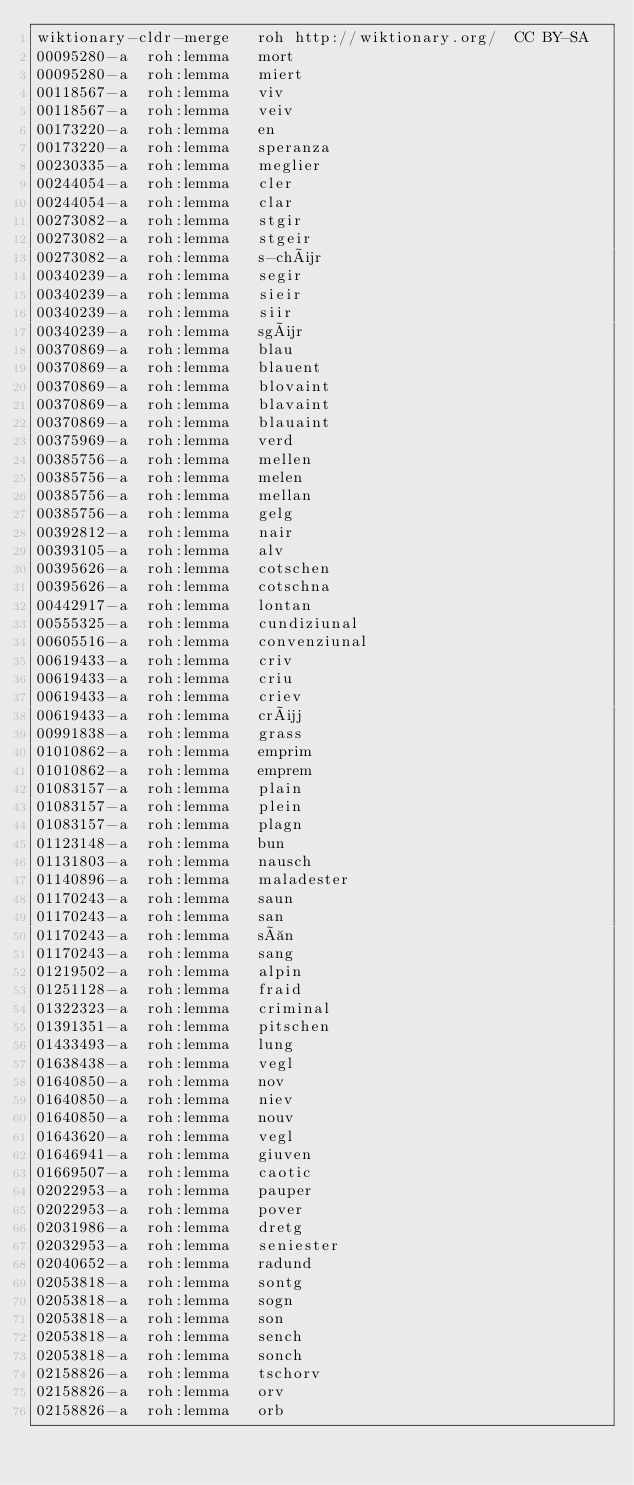<code> <loc_0><loc_0><loc_500><loc_500><_SQL_>wiktionary-cldr-merge	roh	http://wiktionary.org/	CC BY-SA
00095280-a	roh:lemma	mort	
00095280-a	roh:lemma	miert	
00118567-a	roh:lemma	viv	
00118567-a	roh:lemma	veiv	
00173220-a	roh:lemma	en	
00173220-a	roh:lemma	speranza	
00230335-a	roh:lemma	meglier	
00244054-a	roh:lemma	cler	
00244054-a	roh:lemma	clar	
00273082-a	roh:lemma	stgir	
00273082-a	roh:lemma	stgeir	
00273082-a	roh:lemma	s-chür	
00340239-a	roh:lemma	segir	
00340239-a	roh:lemma	sieir	
00340239-a	roh:lemma	siir	
00340239-a	roh:lemma	sgür	
00370869-a	roh:lemma	blau	
00370869-a	roh:lemma	blauent	
00370869-a	roh:lemma	blovaint	
00370869-a	roh:lemma	blavaint	
00370869-a	roh:lemma	blauaint	
00375969-a	roh:lemma	verd	
00385756-a	roh:lemma	mellen	
00385756-a	roh:lemma	melen	
00385756-a	roh:lemma	mellan	
00385756-a	roh:lemma	gelg	
00392812-a	roh:lemma	nair	
00393105-a	roh:lemma	alv	
00395626-a	roh:lemma	cotschen	
00395626-a	roh:lemma	cotschna	
00442917-a	roh:lemma	lontan	
00555325-a	roh:lemma	cundiziunal	
00605516-a	roh:lemma	convenziunal	
00619433-a	roh:lemma	criv	
00619433-a	roh:lemma	criu	
00619433-a	roh:lemma	criev	
00619433-a	roh:lemma	crüj	
00991838-a	roh:lemma	grass	
01010862-a	roh:lemma	emprim	
01010862-a	roh:lemma	emprem	
01083157-a	roh:lemma	plain	
01083157-a	roh:lemma	plein	
01083157-a	roh:lemma	plagn	
01123148-a	roh:lemma	bun	
01131803-a	roh:lemma	nausch	
01140896-a	roh:lemma	maladester	
01170243-a	roh:lemma	saun	
01170243-a	roh:lemma	san	
01170243-a	roh:lemma	sàn	
01170243-a	roh:lemma	sang	
01219502-a	roh:lemma	alpin	
01251128-a	roh:lemma	fraid	
01322323-a	roh:lemma	criminal	
01391351-a	roh:lemma	pitschen	
01433493-a	roh:lemma	lung	
01638438-a	roh:lemma	vegl	
01640850-a	roh:lemma	nov	
01640850-a	roh:lemma	niev	
01640850-a	roh:lemma	nouv	
01643620-a	roh:lemma	vegl	
01646941-a	roh:lemma	giuven	
01669507-a	roh:lemma	caotic	
02022953-a	roh:lemma	pauper	
02022953-a	roh:lemma	pover	
02031986-a	roh:lemma	dretg	
02032953-a	roh:lemma	seniester	
02040652-a	roh:lemma	radund	
02053818-a	roh:lemma	sontg	
02053818-a	roh:lemma	sogn	
02053818-a	roh:lemma	son	
02053818-a	roh:lemma	sench	
02053818-a	roh:lemma	sonch	
02158826-a	roh:lemma	tschorv	
02158826-a	roh:lemma	orv	
02158826-a	roh:lemma	orb	</code> 